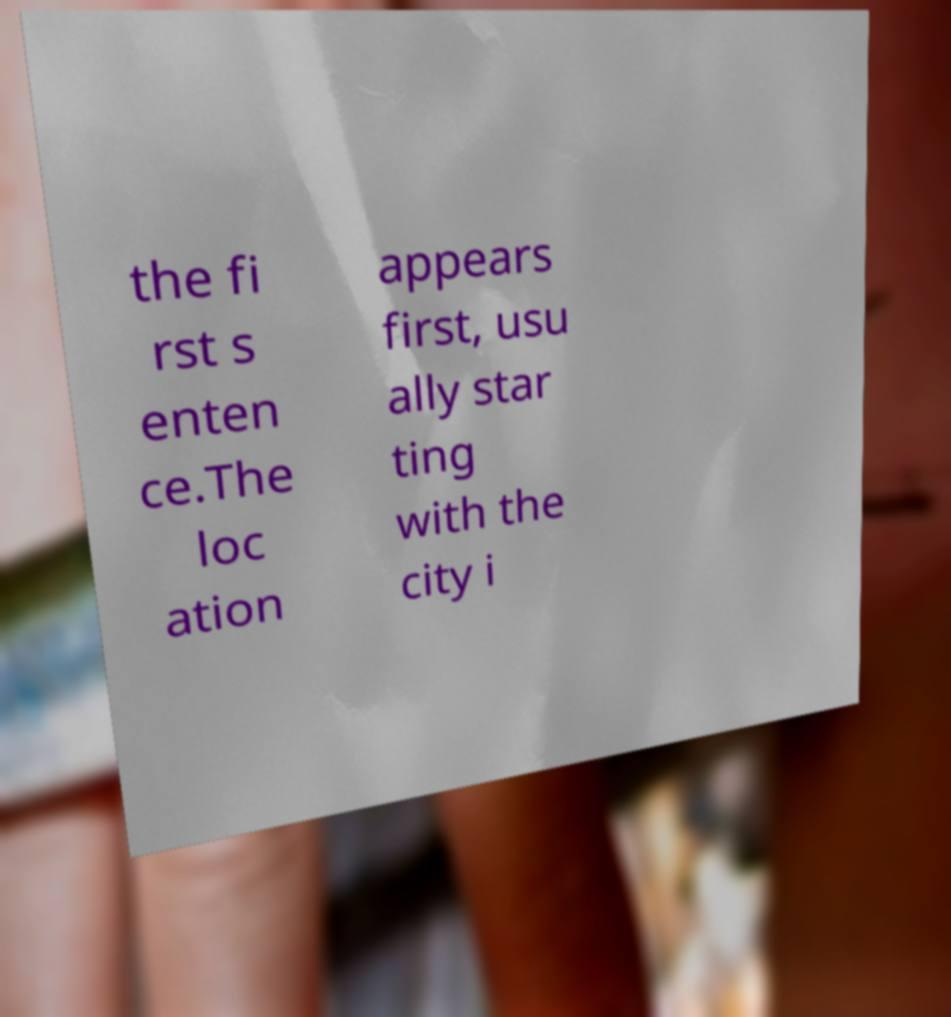Could you extract and type out the text from this image? the fi rst s enten ce.The loc ation appears first, usu ally star ting with the city i 